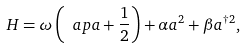<formula> <loc_0><loc_0><loc_500><loc_500>H = \omega \left ( \ a p a + \frac { 1 } { 2 } \right ) + \alpha a ^ { 2 } + \beta a ^ { \dagger 2 } ,</formula> 